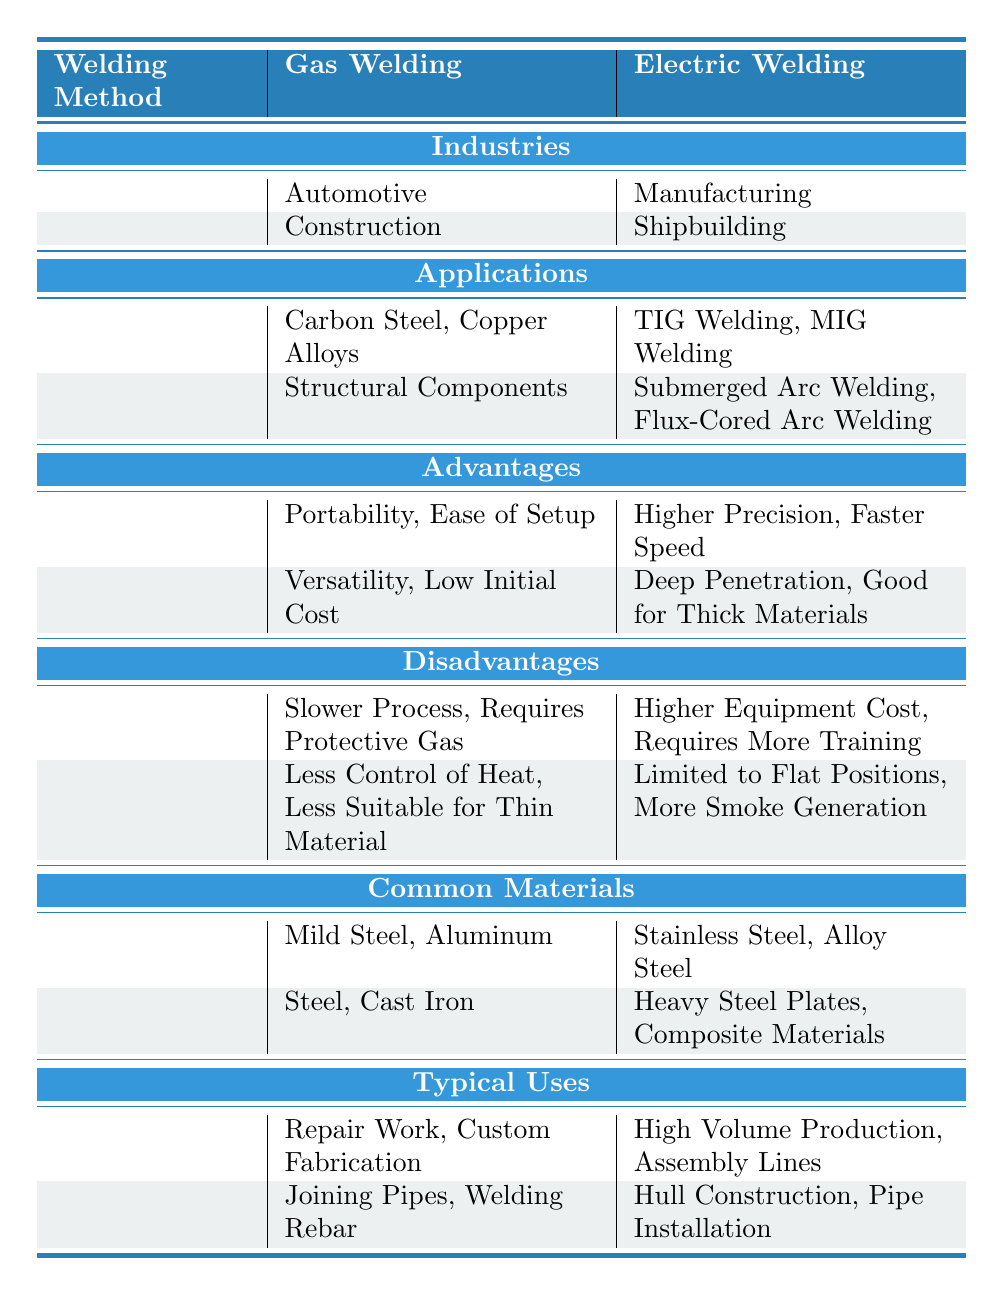What industries utilize gas welding? To find the industries that utilize gas welding, we look under the "Gas Welding" column in the table. The listed industries are Automotive and Construction.
Answer: Automotive, Construction Which advantages are associated with electric welding? We can determine the advantages associated with electric welding by referring to the "Advantages" section under the "Electric Welding" column. The advantages listed are Higher Precision and Faster Speed.
Answer: Higher Precision, Faster Speed Is gas welding suitable for thin materials? To answer this question, we check the disadvantages listed under gas welding. One of the disadvantages states "Less Suitable for Thin Material," indicating that it is not suitable.
Answer: No What applications are common in shipbuilding? By examining the "Shipbuilding" row in the "Applications" section under electric welding, we can see that Submerged Arc Welding and Flux-Cored Arc Welding are common applications in this industry.
Answer: Submerged Arc Welding, Flux-Cored Arc Welding Which welding method is typically faster in the manufacturing industry? Looking under the Manufacturing industry, we find that electric welding has the advantage of "Faster Speed" compared to gas welding. This implies that electric welding is the faster method in this context.
Answer: Electric welding How do the typical uses of gas welding compare to those of electric welding? By analyzing the "Typical Uses" section for both gas welding and electric welding, we see that gas welding is used for Repair Work and Custom Fabrication, while electric welding is used for High Volume Production and Assembly Lines. The comparison shows that gas welding focuses on repair and custom work, while electric welding emphasizes mass production.
Answer: Different focuses: Gas welding is for repair; electric welding is for mass production What materials are commonly welded using gas and electric methods? Referring to the "Common Materials" section, gas welding commonly involves Mild Steel and Aluminum, whereas electric welding involves Stainless Steel and Alloy Steel. This indicates different material preferences in the methods.
Answer: Gas: Mild Steel, Aluminum; Electric: Stainless Steel, Alloy Steel Are gas welding advantages more significant than its disadvantages? By reviewing the advantages (Portability, Ease of Setup) and disadvantages (Slower Process, Requires Protective Gas) listed for gas welding, we consider that advantages could be seen as greater for portable, simpler tasks, while disadvantages highlight limitations. However, the assessment depends on specific use cases, so it's ambiguous.
Answer: Ambiguous, depends on use case What welding method offers better heat control? According to the "Disadvantages" of both welding methods, gas welding has "Less Control of Heat." In contrast, electric welding does not mention this as a disadvantage, which suggests that electric welding offers better heat control.
Answer: Electric welding 